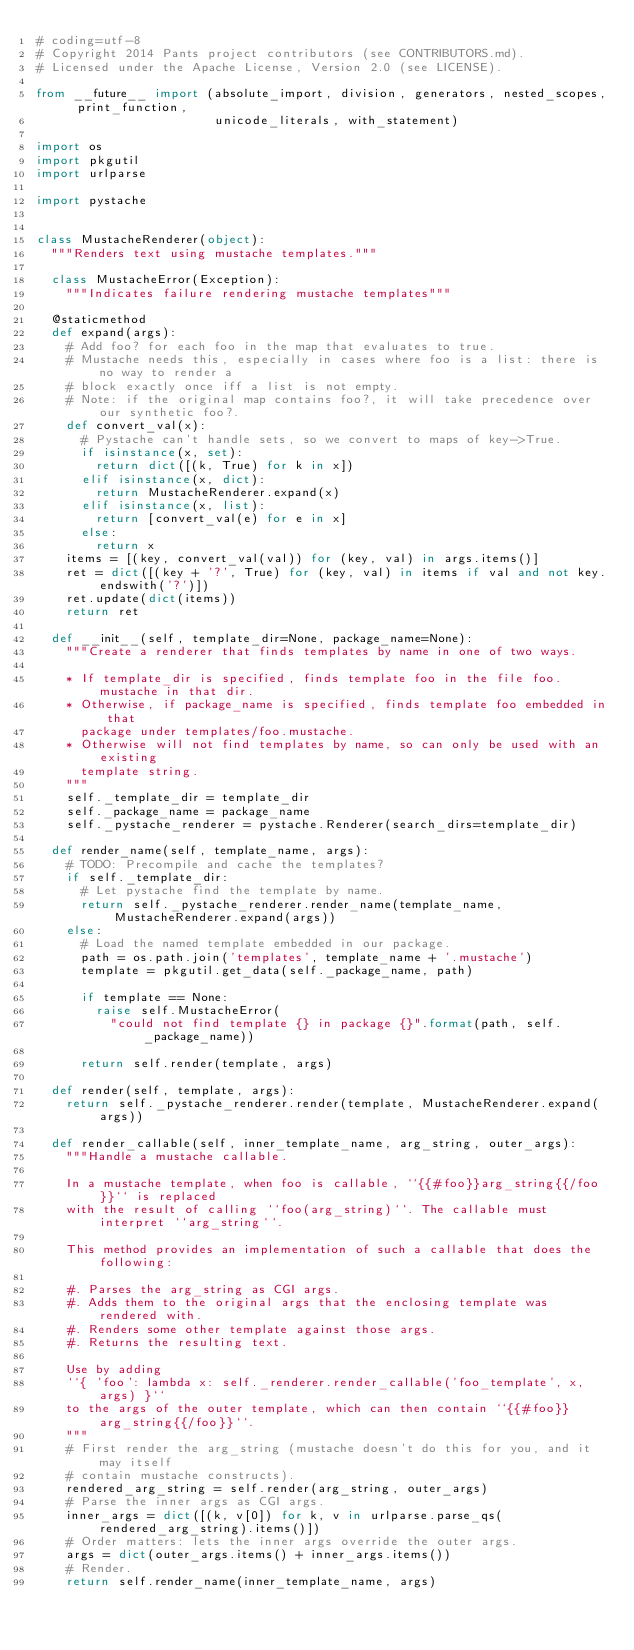<code> <loc_0><loc_0><loc_500><loc_500><_Python_># coding=utf-8
# Copyright 2014 Pants project contributors (see CONTRIBUTORS.md).
# Licensed under the Apache License, Version 2.0 (see LICENSE).

from __future__ import (absolute_import, division, generators, nested_scopes, print_function,
                        unicode_literals, with_statement)

import os
import pkgutil
import urlparse

import pystache


class MustacheRenderer(object):
  """Renders text using mustache templates."""

  class MustacheError(Exception):
    """Indicates failure rendering mustache templates"""

  @staticmethod
  def expand(args):
    # Add foo? for each foo in the map that evaluates to true.
    # Mustache needs this, especially in cases where foo is a list: there is no way to render a
    # block exactly once iff a list is not empty.
    # Note: if the original map contains foo?, it will take precedence over our synthetic foo?.
    def convert_val(x):
      # Pystache can't handle sets, so we convert to maps of key->True.
      if isinstance(x, set):
        return dict([(k, True) for k in x])
      elif isinstance(x, dict):
        return MustacheRenderer.expand(x)
      elif isinstance(x, list):
        return [convert_val(e) for e in x]
      else:
        return x
    items = [(key, convert_val(val)) for (key, val) in args.items()]
    ret = dict([(key + '?', True) for (key, val) in items if val and not key.endswith('?')])
    ret.update(dict(items))
    return ret

  def __init__(self, template_dir=None, package_name=None):
    """Create a renderer that finds templates by name in one of two ways.

    * If template_dir is specified, finds template foo in the file foo.mustache in that dir.
    * Otherwise, if package_name is specified, finds template foo embedded in that
      package under templates/foo.mustache.
    * Otherwise will not find templates by name, so can only be used with an existing
      template string.
    """
    self._template_dir = template_dir
    self._package_name = package_name
    self._pystache_renderer = pystache.Renderer(search_dirs=template_dir)

  def render_name(self, template_name, args):
    # TODO: Precompile and cache the templates?
    if self._template_dir:
      # Let pystache find the template by name.
      return self._pystache_renderer.render_name(template_name, MustacheRenderer.expand(args))
    else:
      # Load the named template embedded in our package.
      path = os.path.join('templates', template_name + '.mustache')
      template = pkgutil.get_data(self._package_name, path)

      if template == None:
        raise self.MustacheError(
          "could not find template {} in package {}".format(path, self._package_name))

      return self.render(template, args)

  def render(self, template, args):
    return self._pystache_renderer.render(template, MustacheRenderer.expand(args))

  def render_callable(self, inner_template_name, arg_string, outer_args):
    """Handle a mustache callable.

    In a mustache template, when foo is callable, ``{{#foo}}arg_string{{/foo}}`` is replaced
    with the result of calling ``foo(arg_string)``. The callable must interpret ``arg_string``.

    This method provides an implementation of such a callable that does the following:

    #. Parses the arg_string as CGI args.
    #. Adds them to the original args that the enclosing template was rendered with.
    #. Renders some other template against those args.
    #. Returns the resulting text.

    Use by adding
    ``{ 'foo': lambda x: self._renderer.render_callable('foo_template', x, args) }``
    to the args of the outer template, which can then contain ``{{#foo}}arg_string{{/foo}}``.
    """
    # First render the arg_string (mustache doesn't do this for you, and it may itself
    # contain mustache constructs).
    rendered_arg_string = self.render(arg_string, outer_args)
    # Parse the inner args as CGI args.
    inner_args = dict([(k, v[0]) for k, v in urlparse.parse_qs(rendered_arg_string).items()])
    # Order matters: lets the inner args override the outer args.
    args = dict(outer_args.items() + inner_args.items())
    # Render.
    return self.render_name(inner_template_name, args)
</code> 